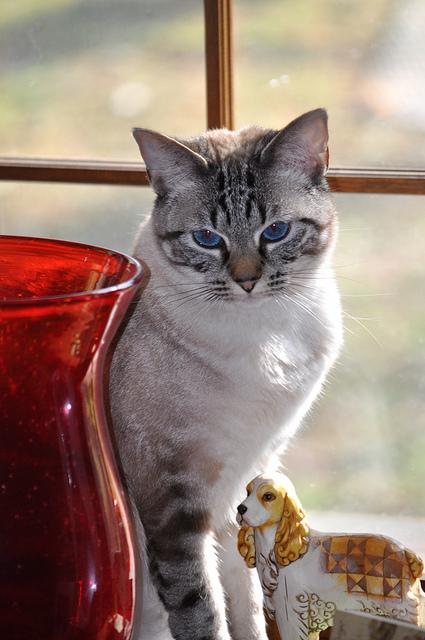Does this cat want to play with the little dog?
Give a very brief answer. No. What color is the vase?
Answer briefly. Red. What figurine is next to the cat?
Answer briefly. Dog. 